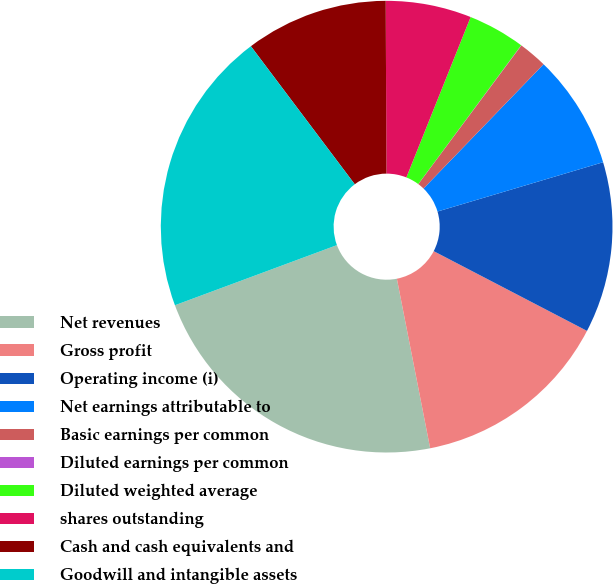<chart> <loc_0><loc_0><loc_500><loc_500><pie_chart><fcel>Net revenues<fcel>Gross profit<fcel>Operating income (i)<fcel>Net earnings attributable to<fcel>Basic earnings per common<fcel>Diluted earnings per common<fcel>Diluted weighted average<fcel>shares outstanding<fcel>Cash and cash equivalents and<fcel>Goodwill and intangible assets<nl><fcel>22.43%<fcel>14.28%<fcel>12.24%<fcel>8.17%<fcel>2.05%<fcel>0.02%<fcel>4.09%<fcel>6.13%<fcel>10.2%<fcel>20.39%<nl></chart> 